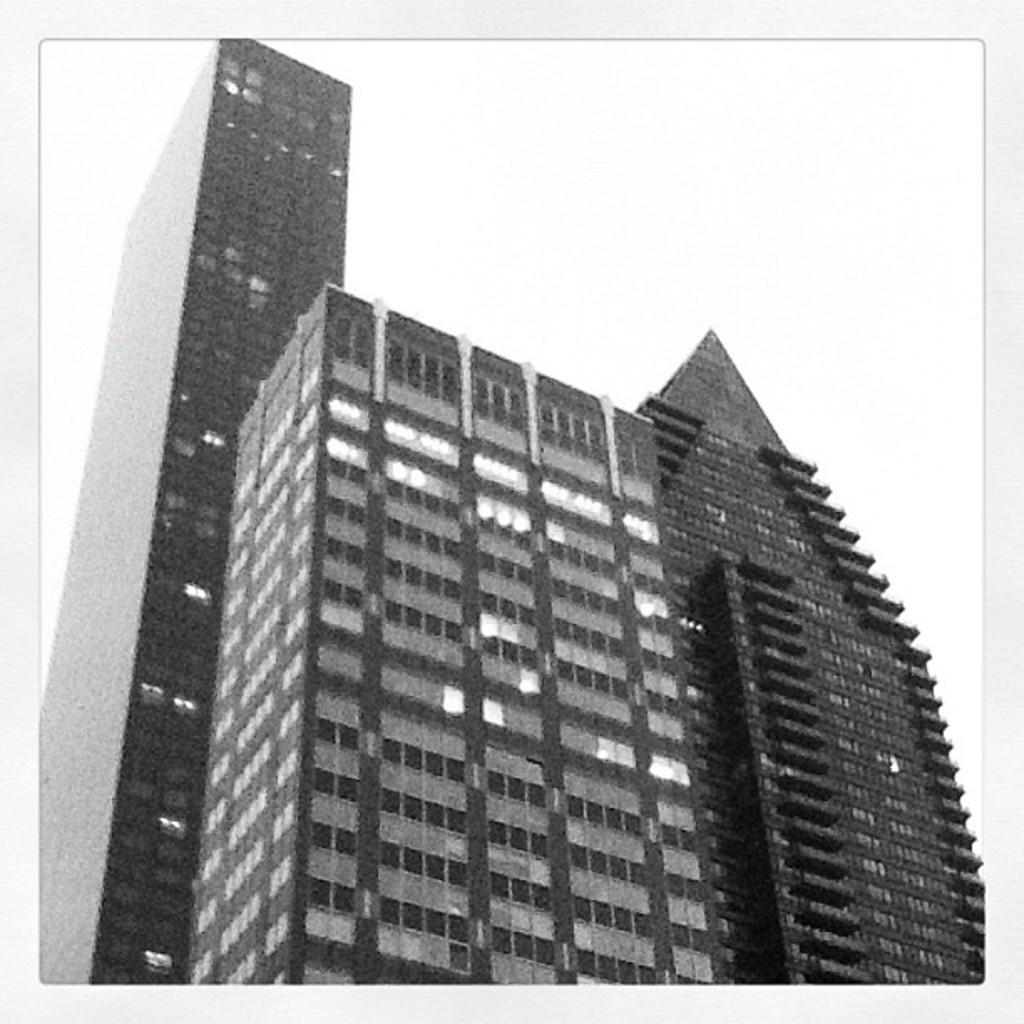What is the color scheme of the image? The image is black and white. What can be seen in the image besides the sky? There is a group of buildings in the image. What part of the natural environment is visible in the image? The sky is visible in the image. How many rings can be seen on the paper in the image? There is no paper or rings present in the image. 